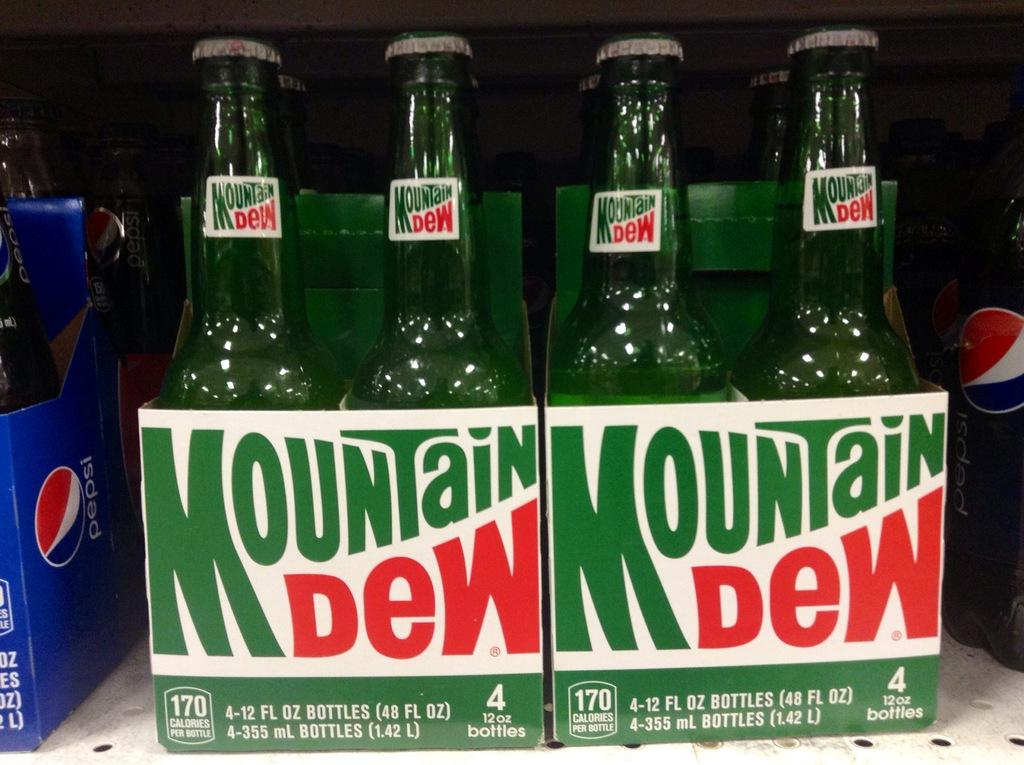<image>
Render a clear and concise summary of the photo. Two 4 packs of bottles of Mountain Dew 